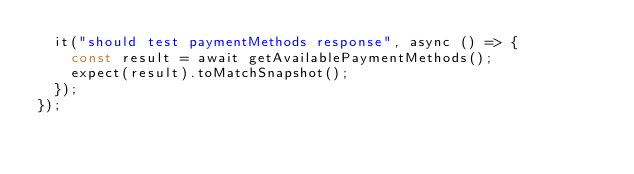Convert code to text. <code><loc_0><loc_0><loc_500><loc_500><_TypeScript_>  it("should test paymentMethods response", async () => {
    const result = await getAvailablePaymentMethods();
    expect(result).toMatchSnapshot();
  });
});
</code> 